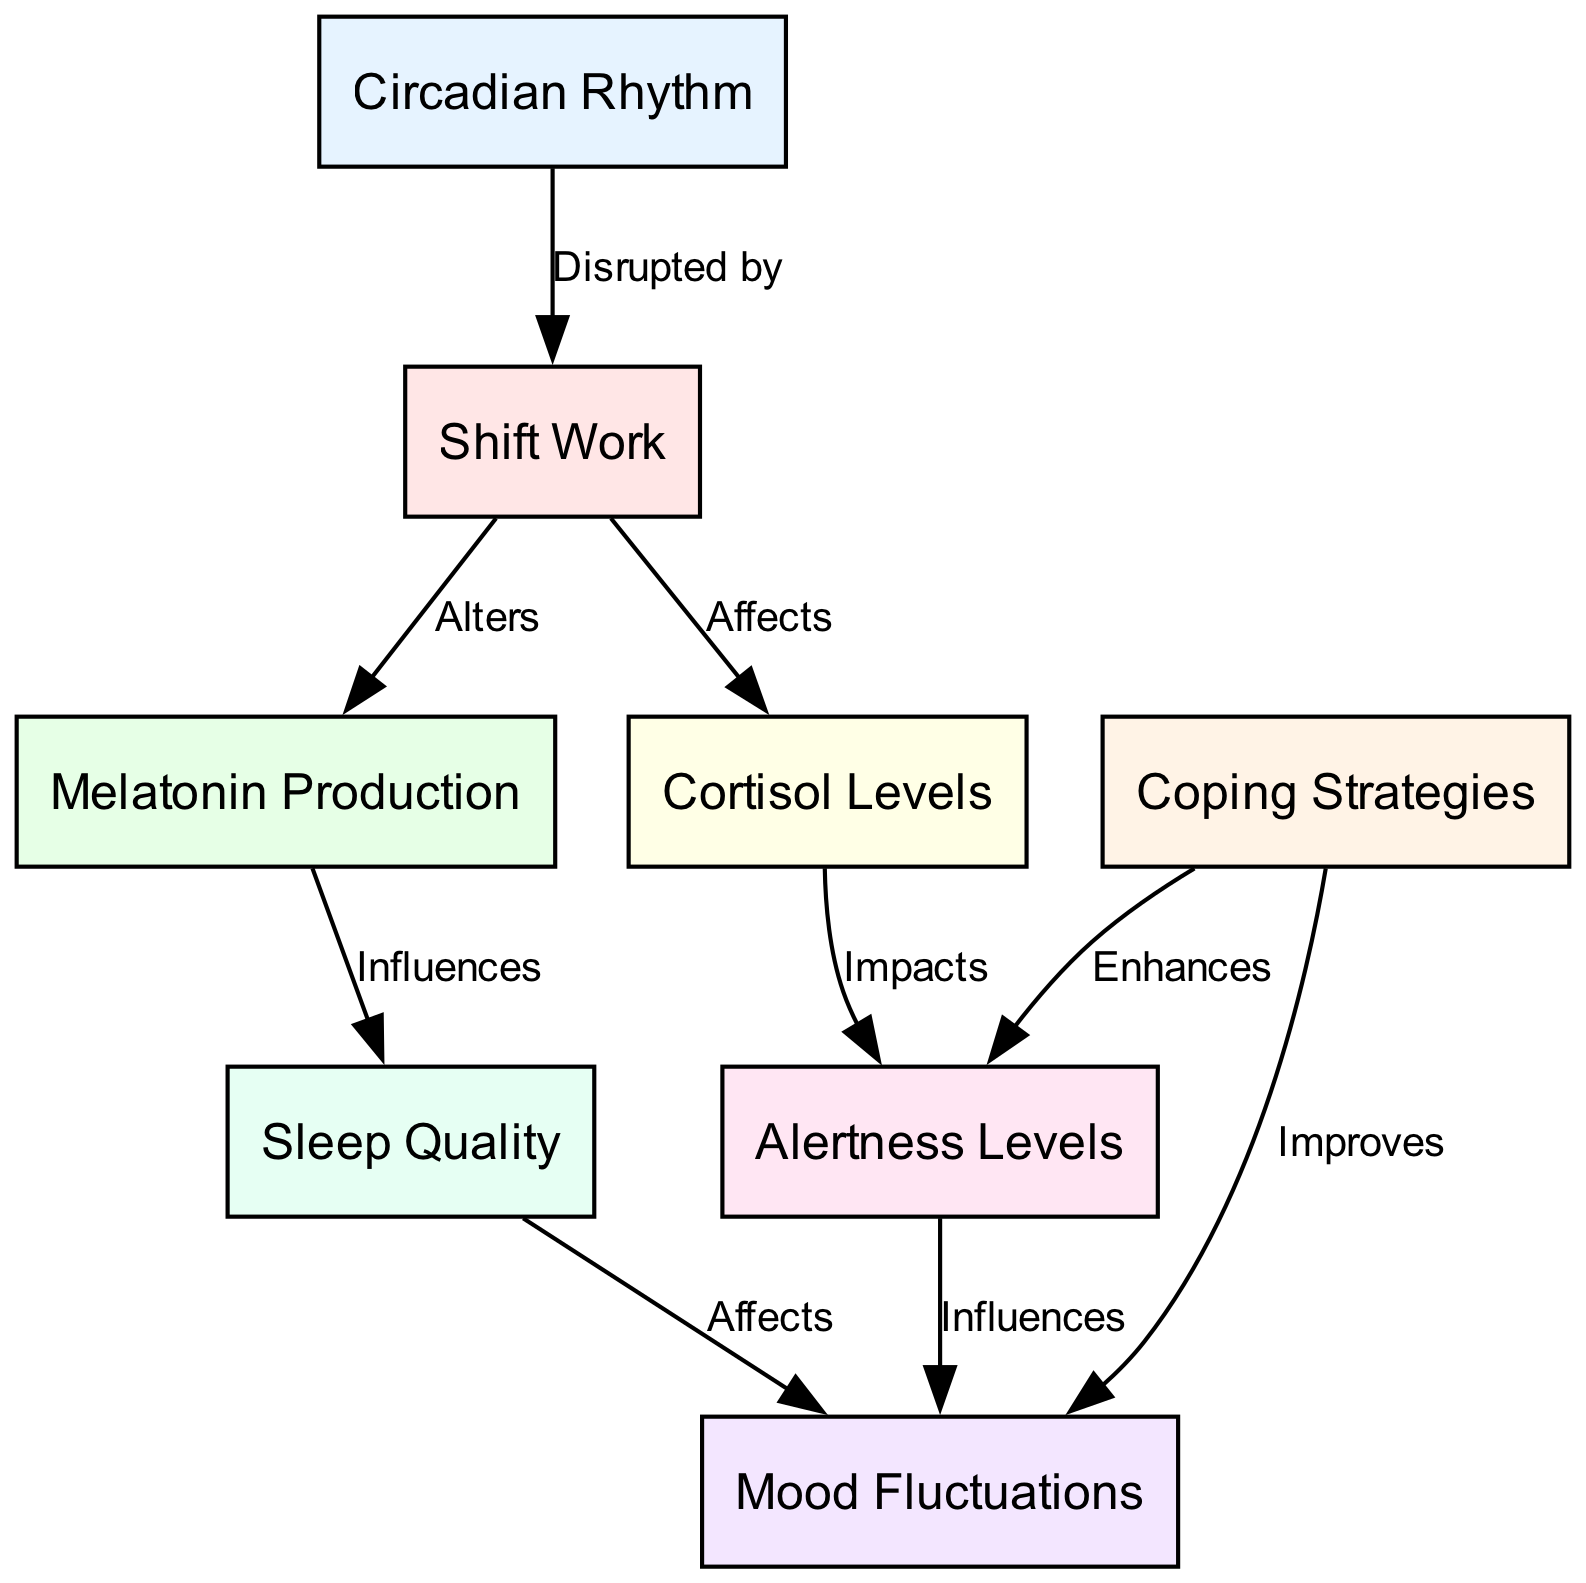What is the total number of nodes in the diagram? There are eight nodes present in the diagram, which include Circadian Rhythm, Shift Work, Melatonin Production, Cortisol Levels, Mood Fluctuations, Alertness Levels, Sleep Quality, and Coping Strategies.
Answer: 8 How does shift work affect melatonin production? The diagram indicates that shift work alters melatonin production, representing a direct relationship between these two nodes.
Answer: Alters What is the impact of cortisol levels on alertness? The diagram shows a one-way relationship from cortisol levels to alertness, stating that cortisol impacts alertness.
Answer: Impacts Which factor can improve mood according to the diagram? The diagram specifies that coping strategies can improve mood, signifying a positive influence from this node.
Answer: Coping Strategies Describe the relationship between sleep quality and mood. The diagram indicates that sleep quality affects mood, suggesting that better sleep quality likely leads to improved mood.
Answer: Affects How many edges are there in the diagram? There are eight directed edges that illustrate the relationships between the nodes in the diagram, connecting them in various ways.
Answer: 8 What influences sleep quality according to the diagram? The diagram reveals that melatonin production influences sleep quality, establishing a causal relationship.
Answer: Influences How do coping strategies enhance alertness? Per the diagram, the coping strategies enhance alertness, indicating a beneficial effect on maintaining awareness levels.
Answer: Enhances What is the relationship between alertness levels and mood? The diagram shows that alertness levels influence mood, suggesting that a person's state of alertness can impact their emotional state.
Answer: Influences 